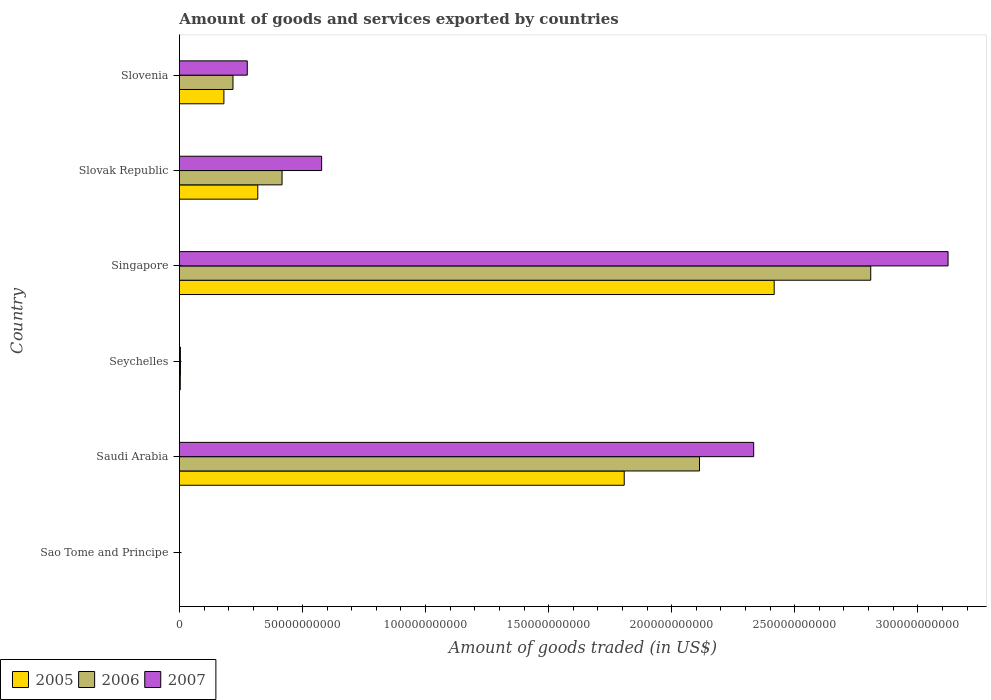How many different coloured bars are there?
Offer a very short reply. 3. How many bars are there on the 1st tick from the bottom?
Your answer should be compact. 3. What is the label of the 6th group of bars from the top?
Offer a very short reply. Sao Tome and Principe. In how many cases, is the number of bars for a given country not equal to the number of legend labels?
Keep it short and to the point. 0. What is the total amount of goods and services exported in 2005 in Sao Tome and Principe?
Offer a very short reply. 6.79e+06. Across all countries, what is the maximum total amount of goods and services exported in 2006?
Your answer should be very brief. 2.81e+11. Across all countries, what is the minimum total amount of goods and services exported in 2005?
Provide a succinct answer. 6.79e+06. In which country was the total amount of goods and services exported in 2007 maximum?
Ensure brevity in your answer.  Singapore. In which country was the total amount of goods and services exported in 2005 minimum?
Offer a terse response. Sao Tome and Principe. What is the total total amount of goods and services exported in 2006 in the graph?
Keep it short and to the point. 5.56e+11. What is the difference between the total amount of goods and services exported in 2007 in Sao Tome and Principe and that in Seychelles?
Offer a terse response. -3.91e+08. What is the difference between the total amount of goods and services exported in 2006 in Singapore and the total amount of goods and services exported in 2007 in Seychelles?
Give a very brief answer. 2.80e+11. What is the average total amount of goods and services exported in 2005 per country?
Provide a short and direct response. 7.88e+1. What is the difference between the total amount of goods and services exported in 2006 and total amount of goods and services exported in 2007 in Saudi Arabia?
Offer a terse response. -2.20e+1. In how many countries, is the total amount of goods and services exported in 2006 greater than 200000000000 US$?
Offer a terse response. 2. What is the ratio of the total amount of goods and services exported in 2006 in Seychelles to that in Slovak Republic?
Offer a very short reply. 0.01. Is the total amount of goods and services exported in 2006 in Saudi Arabia less than that in Singapore?
Your answer should be compact. Yes. Is the difference between the total amount of goods and services exported in 2006 in Sao Tome and Principe and Saudi Arabia greater than the difference between the total amount of goods and services exported in 2007 in Sao Tome and Principe and Saudi Arabia?
Offer a very short reply. Yes. What is the difference between the highest and the second highest total amount of goods and services exported in 2005?
Offer a very short reply. 6.09e+1. What is the difference between the highest and the lowest total amount of goods and services exported in 2006?
Offer a terse response. 2.81e+11. In how many countries, is the total amount of goods and services exported in 2005 greater than the average total amount of goods and services exported in 2005 taken over all countries?
Give a very brief answer. 2. What does the 2nd bar from the bottom in Sao Tome and Principe represents?
Your response must be concise. 2006. How many bars are there?
Offer a terse response. 18. How many legend labels are there?
Offer a very short reply. 3. What is the title of the graph?
Ensure brevity in your answer.  Amount of goods and services exported by countries. Does "1964" appear as one of the legend labels in the graph?
Offer a very short reply. No. What is the label or title of the X-axis?
Offer a terse response. Amount of goods traded (in US$). What is the Amount of goods traded (in US$) of 2005 in Sao Tome and Principe?
Keep it short and to the point. 6.79e+06. What is the Amount of goods traded (in US$) in 2006 in Sao Tome and Principe?
Make the answer very short. 7.71e+06. What is the Amount of goods traded (in US$) of 2007 in Sao Tome and Principe?
Keep it short and to the point. 6.81e+06. What is the Amount of goods traded (in US$) of 2005 in Saudi Arabia?
Give a very brief answer. 1.81e+11. What is the Amount of goods traded (in US$) in 2006 in Saudi Arabia?
Give a very brief answer. 2.11e+11. What is the Amount of goods traded (in US$) of 2007 in Saudi Arabia?
Make the answer very short. 2.33e+11. What is the Amount of goods traded (in US$) in 2005 in Seychelles?
Ensure brevity in your answer.  3.50e+08. What is the Amount of goods traded (in US$) in 2006 in Seychelles?
Provide a succinct answer. 4.19e+08. What is the Amount of goods traded (in US$) of 2007 in Seychelles?
Offer a terse response. 3.98e+08. What is the Amount of goods traded (in US$) in 2005 in Singapore?
Keep it short and to the point. 2.42e+11. What is the Amount of goods traded (in US$) in 2006 in Singapore?
Your response must be concise. 2.81e+11. What is the Amount of goods traded (in US$) in 2007 in Singapore?
Offer a very short reply. 3.12e+11. What is the Amount of goods traded (in US$) in 2005 in Slovak Republic?
Make the answer very short. 3.18e+1. What is the Amount of goods traded (in US$) of 2006 in Slovak Republic?
Your response must be concise. 4.17e+1. What is the Amount of goods traded (in US$) in 2007 in Slovak Republic?
Make the answer very short. 5.78e+1. What is the Amount of goods traded (in US$) in 2005 in Slovenia?
Provide a short and direct response. 1.81e+1. What is the Amount of goods traded (in US$) of 2006 in Slovenia?
Your response must be concise. 2.18e+1. What is the Amount of goods traded (in US$) of 2007 in Slovenia?
Provide a short and direct response. 2.76e+1. Across all countries, what is the maximum Amount of goods traded (in US$) in 2005?
Offer a terse response. 2.42e+11. Across all countries, what is the maximum Amount of goods traded (in US$) of 2006?
Provide a short and direct response. 2.81e+11. Across all countries, what is the maximum Amount of goods traded (in US$) of 2007?
Ensure brevity in your answer.  3.12e+11. Across all countries, what is the minimum Amount of goods traded (in US$) of 2005?
Your answer should be very brief. 6.79e+06. Across all countries, what is the minimum Amount of goods traded (in US$) of 2006?
Offer a very short reply. 7.71e+06. Across all countries, what is the minimum Amount of goods traded (in US$) of 2007?
Ensure brevity in your answer.  6.81e+06. What is the total Amount of goods traded (in US$) of 2005 in the graph?
Give a very brief answer. 4.73e+11. What is the total Amount of goods traded (in US$) of 2006 in the graph?
Make the answer very short. 5.56e+11. What is the total Amount of goods traded (in US$) of 2007 in the graph?
Ensure brevity in your answer.  6.31e+11. What is the difference between the Amount of goods traded (in US$) in 2005 in Sao Tome and Principe and that in Saudi Arabia?
Your answer should be compact. -1.81e+11. What is the difference between the Amount of goods traded (in US$) of 2006 in Sao Tome and Principe and that in Saudi Arabia?
Make the answer very short. -2.11e+11. What is the difference between the Amount of goods traded (in US$) in 2007 in Sao Tome and Principe and that in Saudi Arabia?
Your answer should be very brief. -2.33e+11. What is the difference between the Amount of goods traded (in US$) of 2005 in Sao Tome and Principe and that in Seychelles?
Offer a terse response. -3.43e+08. What is the difference between the Amount of goods traded (in US$) of 2006 in Sao Tome and Principe and that in Seychelles?
Keep it short and to the point. -4.11e+08. What is the difference between the Amount of goods traded (in US$) in 2007 in Sao Tome and Principe and that in Seychelles?
Give a very brief answer. -3.91e+08. What is the difference between the Amount of goods traded (in US$) of 2005 in Sao Tome and Principe and that in Singapore?
Provide a short and direct response. -2.42e+11. What is the difference between the Amount of goods traded (in US$) in 2006 in Sao Tome and Principe and that in Singapore?
Your answer should be very brief. -2.81e+11. What is the difference between the Amount of goods traded (in US$) of 2007 in Sao Tome and Principe and that in Singapore?
Provide a succinct answer. -3.12e+11. What is the difference between the Amount of goods traded (in US$) of 2005 in Sao Tome and Principe and that in Slovak Republic?
Your answer should be very brief. -3.18e+1. What is the difference between the Amount of goods traded (in US$) of 2006 in Sao Tome and Principe and that in Slovak Republic?
Offer a very short reply. -4.17e+1. What is the difference between the Amount of goods traded (in US$) of 2007 in Sao Tome and Principe and that in Slovak Republic?
Provide a short and direct response. -5.78e+1. What is the difference between the Amount of goods traded (in US$) in 2005 in Sao Tome and Principe and that in Slovenia?
Offer a very short reply. -1.81e+1. What is the difference between the Amount of goods traded (in US$) of 2006 in Sao Tome and Principe and that in Slovenia?
Your answer should be very brief. -2.18e+1. What is the difference between the Amount of goods traded (in US$) of 2007 in Sao Tome and Principe and that in Slovenia?
Your answer should be very brief. -2.76e+1. What is the difference between the Amount of goods traded (in US$) in 2005 in Saudi Arabia and that in Seychelles?
Provide a short and direct response. 1.80e+11. What is the difference between the Amount of goods traded (in US$) of 2006 in Saudi Arabia and that in Seychelles?
Make the answer very short. 2.11e+11. What is the difference between the Amount of goods traded (in US$) of 2007 in Saudi Arabia and that in Seychelles?
Offer a very short reply. 2.33e+11. What is the difference between the Amount of goods traded (in US$) in 2005 in Saudi Arabia and that in Singapore?
Your answer should be compact. -6.09e+1. What is the difference between the Amount of goods traded (in US$) of 2006 in Saudi Arabia and that in Singapore?
Ensure brevity in your answer.  -6.96e+1. What is the difference between the Amount of goods traded (in US$) in 2007 in Saudi Arabia and that in Singapore?
Your answer should be very brief. -7.90e+1. What is the difference between the Amount of goods traded (in US$) of 2005 in Saudi Arabia and that in Slovak Republic?
Keep it short and to the point. 1.49e+11. What is the difference between the Amount of goods traded (in US$) in 2006 in Saudi Arabia and that in Slovak Republic?
Keep it short and to the point. 1.70e+11. What is the difference between the Amount of goods traded (in US$) in 2007 in Saudi Arabia and that in Slovak Republic?
Provide a succinct answer. 1.76e+11. What is the difference between the Amount of goods traded (in US$) of 2005 in Saudi Arabia and that in Slovenia?
Make the answer very short. 1.63e+11. What is the difference between the Amount of goods traded (in US$) in 2006 in Saudi Arabia and that in Slovenia?
Offer a very short reply. 1.90e+11. What is the difference between the Amount of goods traded (in US$) in 2007 in Saudi Arabia and that in Slovenia?
Provide a succinct answer. 2.06e+11. What is the difference between the Amount of goods traded (in US$) in 2005 in Seychelles and that in Singapore?
Your answer should be compact. -2.41e+11. What is the difference between the Amount of goods traded (in US$) of 2006 in Seychelles and that in Singapore?
Your answer should be compact. -2.80e+11. What is the difference between the Amount of goods traded (in US$) of 2007 in Seychelles and that in Singapore?
Provide a short and direct response. -3.12e+11. What is the difference between the Amount of goods traded (in US$) in 2005 in Seychelles and that in Slovak Republic?
Your response must be concise. -3.15e+1. What is the difference between the Amount of goods traded (in US$) of 2006 in Seychelles and that in Slovak Republic?
Your response must be concise. -4.13e+1. What is the difference between the Amount of goods traded (in US$) in 2007 in Seychelles and that in Slovak Republic?
Keep it short and to the point. -5.74e+1. What is the difference between the Amount of goods traded (in US$) of 2005 in Seychelles and that in Slovenia?
Make the answer very short. -1.77e+1. What is the difference between the Amount of goods traded (in US$) in 2006 in Seychelles and that in Slovenia?
Keep it short and to the point. -2.13e+1. What is the difference between the Amount of goods traded (in US$) in 2007 in Seychelles and that in Slovenia?
Provide a succinct answer. -2.72e+1. What is the difference between the Amount of goods traded (in US$) in 2005 in Singapore and that in Slovak Republic?
Ensure brevity in your answer.  2.10e+11. What is the difference between the Amount of goods traded (in US$) in 2006 in Singapore and that in Slovak Republic?
Offer a very short reply. 2.39e+11. What is the difference between the Amount of goods traded (in US$) in 2007 in Singapore and that in Slovak Republic?
Offer a very short reply. 2.54e+11. What is the difference between the Amount of goods traded (in US$) in 2005 in Singapore and that in Slovenia?
Keep it short and to the point. 2.24e+11. What is the difference between the Amount of goods traded (in US$) of 2006 in Singapore and that in Slovenia?
Provide a succinct answer. 2.59e+11. What is the difference between the Amount of goods traded (in US$) of 2007 in Singapore and that in Slovenia?
Make the answer very short. 2.85e+11. What is the difference between the Amount of goods traded (in US$) of 2005 in Slovak Republic and that in Slovenia?
Your response must be concise. 1.38e+1. What is the difference between the Amount of goods traded (in US$) in 2006 in Slovak Republic and that in Slovenia?
Your response must be concise. 1.99e+1. What is the difference between the Amount of goods traded (in US$) of 2007 in Slovak Republic and that in Slovenia?
Keep it short and to the point. 3.02e+1. What is the difference between the Amount of goods traded (in US$) in 2005 in Sao Tome and Principe and the Amount of goods traded (in US$) in 2006 in Saudi Arabia?
Provide a short and direct response. -2.11e+11. What is the difference between the Amount of goods traded (in US$) of 2005 in Sao Tome and Principe and the Amount of goods traded (in US$) of 2007 in Saudi Arabia?
Provide a short and direct response. -2.33e+11. What is the difference between the Amount of goods traded (in US$) in 2006 in Sao Tome and Principe and the Amount of goods traded (in US$) in 2007 in Saudi Arabia?
Your answer should be very brief. -2.33e+11. What is the difference between the Amount of goods traded (in US$) of 2005 in Sao Tome and Principe and the Amount of goods traded (in US$) of 2006 in Seychelles?
Offer a terse response. -4.12e+08. What is the difference between the Amount of goods traded (in US$) of 2005 in Sao Tome and Principe and the Amount of goods traded (in US$) of 2007 in Seychelles?
Your response must be concise. -3.91e+08. What is the difference between the Amount of goods traded (in US$) in 2006 in Sao Tome and Principe and the Amount of goods traded (in US$) in 2007 in Seychelles?
Give a very brief answer. -3.90e+08. What is the difference between the Amount of goods traded (in US$) of 2005 in Sao Tome and Principe and the Amount of goods traded (in US$) of 2006 in Singapore?
Make the answer very short. -2.81e+11. What is the difference between the Amount of goods traded (in US$) of 2005 in Sao Tome and Principe and the Amount of goods traded (in US$) of 2007 in Singapore?
Your answer should be very brief. -3.12e+11. What is the difference between the Amount of goods traded (in US$) of 2006 in Sao Tome and Principe and the Amount of goods traded (in US$) of 2007 in Singapore?
Keep it short and to the point. -3.12e+11. What is the difference between the Amount of goods traded (in US$) in 2005 in Sao Tome and Principe and the Amount of goods traded (in US$) in 2006 in Slovak Republic?
Provide a succinct answer. -4.17e+1. What is the difference between the Amount of goods traded (in US$) in 2005 in Sao Tome and Principe and the Amount of goods traded (in US$) in 2007 in Slovak Republic?
Your answer should be very brief. -5.78e+1. What is the difference between the Amount of goods traded (in US$) in 2006 in Sao Tome and Principe and the Amount of goods traded (in US$) in 2007 in Slovak Republic?
Make the answer very short. -5.78e+1. What is the difference between the Amount of goods traded (in US$) in 2005 in Sao Tome and Principe and the Amount of goods traded (in US$) in 2006 in Slovenia?
Your answer should be very brief. -2.18e+1. What is the difference between the Amount of goods traded (in US$) of 2005 in Sao Tome and Principe and the Amount of goods traded (in US$) of 2007 in Slovenia?
Ensure brevity in your answer.  -2.76e+1. What is the difference between the Amount of goods traded (in US$) of 2006 in Sao Tome and Principe and the Amount of goods traded (in US$) of 2007 in Slovenia?
Give a very brief answer. -2.76e+1. What is the difference between the Amount of goods traded (in US$) in 2005 in Saudi Arabia and the Amount of goods traded (in US$) in 2006 in Seychelles?
Offer a very short reply. 1.80e+11. What is the difference between the Amount of goods traded (in US$) in 2005 in Saudi Arabia and the Amount of goods traded (in US$) in 2007 in Seychelles?
Offer a very short reply. 1.80e+11. What is the difference between the Amount of goods traded (in US$) in 2006 in Saudi Arabia and the Amount of goods traded (in US$) in 2007 in Seychelles?
Keep it short and to the point. 2.11e+11. What is the difference between the Amount of goods traded (in US$) of 2005 in Saudi Arabia and the Amount of goods traded (in US$) of 2006 in Singapore?
Provide a short and direct response. -1.00e+11. What is the difference between the Amount of goods traded (in US$) of 2005 in Saudi Arabia and the Amount of goods traded (in US$) of 2007 in Singapore?
Provide a short and direct response. -1.32e+11. What is the difference between the Amount of goods traded (in US$) of 2006 in Saudi Arabia and the Amount of goods traded (in US$) of 2007 in Singapore?
Your response must be concise. -1.01e+11. What is the difference between the Amount of goods traded (in US$) in 2005 in Saudi Arabia and the Amount of goods traded (in US$) in 2006 in Slovak Republic?
Your answer should be compact. 1.39e+11. What is the difference between the Amount of goods traded (in US$) in 2005 in Saudi Arabia and the Amount of goods traded (in US$) in 2007 in Slovak Republic?
Make the answer very short. 1.23e+11. What is the difference between the Amount of goods traded (in US$) of 2006 in Saudi Arabia and the Amount of goods traded (in US$) of 2007 in Slovak Republic?
Keep it short and to the point. 1.54e+11. What is the difference between the Amount of goods traded (in US$) in 2005 in Saudi Arabia and the Amount of goods traded (in US$) in 2006 in Slovenia?
Offer a terse response. 1.59e+11. What is the difference between the Amount of goods traded (in US$) in 2005 in Saudi Arabia and the Amount of goods traded (in US$) in 2007 in Slovenia?
Offer a very short reply. 1.53e+11. What is the difference between the Amount of goods traded (in US$) in 2006 in Saudi Arabia and the Amount of goods traded (in US$) in 2007 in Slovenia?
Ensure brevity in your answer.  1.84e+11. What is the difference between the Amount of goods traded (in US$) in 2005 in Seychelles and the Amount of goods traded (in US$) in 2006 in Singapore?
Your answer should be very brief. -2.81e+11. What is the difference between the Amount of goods traded (in US$) of 2005 in Seychelles and the Amount of goods traded (in US$) of 2007 in Singapore?
Make the answer very short. -3.12e+11. What is the difference between the Amount of goods traded (in US$) of 2006 in Seychelles and the Amount of goods traded (in US$) of 2007 in Singapore?
Provide a succinct answer. -3.12e+11. What is the difference between the Amount of goods traded (in US$) in 2005 in Seychelles and the Amount of goods traded (in US$) in 2006 in Slovak Republic?
Offer a very short reply. -4.14e+1. What is the difference between the Amount of goods traded (in US$) of 2005 in Seychelles and the Amount of goods traded (in US$) of 2007 in Slovak Republic?
Provide a short and direct response. -5.74e+1. What is the difference between the Amount of goods traded (in US$) in 2006 in Seychelles and the Amount of goods traded (in US$) in 2007 in Slovak Republic?
Ensure brevity in your answer.  -5.74e+1. What is the difference between the Amount of goods traded (in US$) in 2005 in Seychelles and the Amount of goods traded (in US$) in 2006 in Slovenia?
Make the answer very short. -2.14e+1. What is the difference between the Amount of goods traded (in US$) of 2005 in Seychelles and the Amount of goods traded (in US$) of 2007 in Slovenia?
Your answer should be compact. -2.72e+1. What is the difference between the Amount of goods traded (in US$) of 2006 in Seychelles and the Amount of goods traded (in US$) of 2007 in Slovenia?
Give a very brief answer. -2.72e+1. What is the difference between the Amount of goods traded (in US$) in 2005 in Singapore and the Amount of goods traded (in US$) in 2006 in Slovak Republic?
Give a very brief answer. 2.00e+11. What is the difference between the Amount of goods traded (in US$) in 2005 in Singapore and the Amount of goods traded (in US$) in 2007 in Slovak Republic?
Make the answer very short. 1.84e+11. What is the difference between the Amount of goods traded (in US$) of 2006 in Singapore and the Amount of goods traded (in US$) of 2007 in Slovak Republic?
Offer a very short reply. 2.23e+11. What is the difference between the Amount of goods traded (in US$) of 2005 in Singapore and the Amount of goods traded (in US$) of 2006 in Slovenia?
Ensure brevity in your answer.  2.20e+11. What is the difference between the Amount of goods traded (in US$) in 2005 in Singapore and the Amount of goods traded (in US$) in 2007 in Slovenia?
Your answer should be very brief. 2.14e+11. What is the difference between the Amount of goods traded (in US$) in 2006 in Singapore and the Amount of goods traded (in US$) in 2007 in Slovenia?
Your answer should be very brief. 2.53e+11. What is the difference between the Amount of goods traded (in US$) of 2005 in Slovak Republic and the Amount of goods traded (in US$) of 2006 in Slovenia?
Your answer should be compact. 1.01e+1. What is the difference between the Amount of goods traded (in US$) of 2005 in Slovak Republic and the Amount of goods traded (in US$) of 2007 in Slovenia?
Offer a terse response. 4.27e+09. What is the difference between the Amount of goods traded (in US$) of 2006 in Slovak Republic and the Amount of goods traded (in US$) of 2007 in Slovenia?
Make the answer very short. 1.41e+1. What is the average Amount of goods traded (in US$) in 2005 per country?
Give a very brief answer. 7.88e+1. What is the average Amount of goods traded (in US$) of 2006 per country?
Ensure brevity in your answer.  9.27e+1. What is the average Amount of goods traded (in US$) in 2007 per country?
Ensure brevity in your answer.  1.05e+11. What is the difference between the Amount of goods traded (in US$) of 2005 and Amount of goods traded (in US$) of 2006 in Sao Tome and Principe?
Make the answer very short. -9.20e+05. What is the difference between the Amount of goods traded (in US$) in 2005 and Amount of goods traded (in US$) in 2007 in Sao Tome and Principe?
Provide a succinct answer. -1.96e+04. What is the difference between the Amount of goods traded (in US$) in 2006 and Amount of goods traded (in US$) in 2007 in Sao Tome and Principe?
Ensure brevity in your answer.  9.00e+05. What is the difference between the Amount of goods traded (in US$) of 2005 and Amount of goods traded (in US$) of 2006 in Saudi Arabia?
Your response must be concise. -3.06e+1. What is the difference between the Amount of goods traded (in US$) of 2005 and Amount of goods traded (in US$) of 2007 in Saudi Arabia?
Keep it short and to the point. -5.26e+1. What is the difference between the Amount of goods traded (in US$) of 2006 and Amount of goods traded (in US$) of 2007 in Saudi Arabia?
Your response must be concise. -2.20e+1. What is the difference between the Amount of goods traded (in US$) in 2005 and Amount of goods traded (in US$) in 2006 in Seychelles?
Offer a very short reply. -6.91e+07. What is the difference between the Amount of goods traded (in US$) of 2005 and Amount of goods traded (in US$) of 2007 in Seychelles?
Provide a succinct answer. -4.75e+07. What is the difference between the Amount of goods traded (in US$) in 2006 and Amount of goods traded (in US$) in 2007 in Seychelles?
Keep it short and to the point. 2.16e+07. What is the difference between the Amount of goods traded (in US$) in 2005 and Amount of goods traded (in US$) in 2006 in Singapore?
Provide a succinct answer. -3.92e+1. What is the difference between the Amount of goods traded (in US$) in 2005 and Amount of goods traded (in US$) in 2007 in Singapore?
Your answer should be compact. -7.06e+1. What is the difference between the Amount of goods traded (in US$) of 2006 and Amount of goods traded (in US$) of 2007 in Singapore?
Your answer should be compact. -3.14e+1. What is the difference between the Amount of goods traded (in US$) in 2005 and Amount of goods traded (in US$) in 2006 in Slovak Republic?
Offer a very short reply. -9.86e+09. What is the difference between the Amount of goods traded (in US$) of 2005 and Amount of goods traded (in US$) of 2007 in Slovak Republic?
Make the answer very short. -2.59e+1. What is the difference between the Amount of goods traded (in US$) in 2006 and Amount of goods traded (in US$) in 2007 in Slovak Republic?
Your response must be concise. -1.61e+1. What is the difference between the Amount of goods traded (in US$) in 2005 and Amount of goods traded (in US$) in 2006 in Slovenia?
Make the answer very short. -3.69e+09. What is the difference between the Amount of goods traded (in US$) in 2005 and Amount of goods traded (in US$) in 2007 in Slovenia?
Your response must be concise. -9.50e+09. What is the difference between the Amount of goods traded (in US$) in 2006 and Amount of goods traded (in US$) in 2007 in Slovenia?
Your response must be concise. -5.81e+09. What is the ratio of the Amount of goods traded (in US$) of 2005 in Sao Tome and Principe to that in Saudi Arabia?
Give a very brief answer. 0. What is the ratio of the Amount of goods traded (in US$) of 2006 in Sao Tome and Principe to that in Saudi Arabia?
Ensure brevity in your answer.  0. What is the ratio of the Amount of goods traded (in US$) in 2007 in Sao Tome and Principe to that in Saudi Arabia?
Ensure brevity in your answer.  0. What is the ratio of the Amount of goods traded (in US$) in 2005 in Sao Tome and Principe to that in Seychelles?
Make the answer very short. 0.02. What is the ratio of the Amount of goods traded (in US$) of 2006 in Sao Tome and Principe to that in Seychelles?
Your response must be concise. 0.02. What is the ratio of the Amount of goods traded (in US$) of 2007 in Sao Tome and Principe to that in Seychelles?
Provide a short and direct response. 0.02. What is the ratio of the Amount of goods traded (in US$) of 2006 in Sao Tome and Principe to that in Singapore?
Offer a very short reply. 0. What is the ratio of the Amount of goods traded (in US$) in 2005 in Sao Tome and Principe to that in Slovak Republic?
Your response must be concise. 0. What is the ratio of the Amount of goods traded (in US$) in 2006 in Sao Tome and Principe to that in Slovak Republic?
Offer a very short reply. 0. What is the ratio of the Amount of goods traded (in US$) in 2007 in Sao Tome and Principe to that in Slovak Republic?
Offer a very short reply. 0. What is the ratio of the Amount of goods traded (in US$) of 2007 in Sao Tome and Principe to that in Slovenia?
Provide a short and direct response. 0. What is the ratio of the Amount of goods traded (in US$) of 2005 in Saudi Arabia to that in Seychelles?
Make the answer very short. 516.17. What is the ratio of the Amount of goods traded (in US$) of 2006 in Saudi Arabia to that in Seychelles?
Provide a short and direct response. 504.06. What is the ratio of the Amount of goods traded (in US$) of 2007 in Saudi Arabia to that in Seychelles?
Offer a very short reply. 586.87. What is the ratio of the Amount of goods traded (in US$) in 2005 in Saudi Arabia to that in Singapore?
Keep it short and to the point. 0.75. What is the ratio of the Amount of goods traded (in US$) in 2006 in Saudi Arabia to that in Singapore?
Your response must be concise. 0.75. What is the ratio of the Amount of goods traded (in US$) in 2007 in Saudi Arabia to that in Singapore?
Ensure brevity in your answer.  0.75. What is the ratio of the Amount of goods traded (in US$) in 2005 in Saudi Arabia to that in Slovak Republic?
Your response must be concise. 5.68. What is the ratio of the Amount of goods traded (in US$) in 2006 in Saudi Arabia to that in Slovak Republic?
Offer a terse response. 5.07. What is the ratio of the Amount of goods traded (in US$) of 2007 in Saudi Arabia to that in Slovak Republic?
Your answer should be very brief. 4.04. What is the ratio of the Amount of goods traded (in US$) in 2005 in Saudi Arabia to that in Slovenia?
Your response must be concise. 10. What is the ratio of the Amount of goods traded (in US$) of 2006 in Saudi Arabia to that in Slovenia?
Offer a very short reply. 9.71. What is the ratio of the Amount of goods traded (in US$) of 2007 in Saudi Arabia to that in Slovenia?
Your answer should be very brief. 8.46. What is the ratio of the Amount of goods traded (in US$) in 2005 in Seychelles to that in Singapore?
Make the answer very short. 0. What is the ratio of the Amount of goods traded (in US$) of 2006 in Seychelles to that in Singapore?
Your answer should be compact. 0. What is the ratio of the Amount of goods traded (in US$) of 2007 in Seychelles to that in Singapore?
Make the answer very short. 0. What is the ratio of the Amount of goods traded (in US$) of 2005 in Seychelles to that in Slovak Republic?
Your answer should be compact. 0.01. What is the ratio of the Amount of goods traded (in US$) in 2006 in Seychelles to that in Slovak Republic?
Give a very brief answer. 0.01. What is the ratio of the Amount of goods traded (in US$) of 2007 in Seychelles to that in Slovak Republic?
Ensure brevity in your answer.  0.01. What is the ratio of the Amount of goods traded (in US$) of 2005 in Seychelles to that in Slovenia?
Make the answer very short. 0.02. What is the ratio of the Amount of goods traded (in US$) of 2006 in Seychelles to that in Slovenia?
Keep it short and to the point. 0.02. What is the ratio of the Amount of goods traded (in US$) in 2007 in Seychelles to that in Slovenia?
Offer a very short reply. 0.01. What is the ratio of the Amount of goods traded (in US$) of 2005 in Singapore to that in Slovak Republic?
Give a very brief answer. 7.59. What is the ratio of the Amount of goods traded (in US$) of 2006 in Singapore to that in Slovak Republic?
Provide a succinct answer. 6.73. What is the ratio of the Amount of goods traded (in US$) in 2007 in Singapore to that in Slovak Republic?
Offer a very short reply. 5.4. What is the ratio of the Amount of goods traded (in US$) of 2005 in Singapore to that in Slovenia?
Offer a very short reply. 13.37. What is the ratio of the Amount of goods traded (in US$) in 2006 in Singapore to that in Slovenia?
Offer a terse response. 12.9. What is the ratio of the Amount of goods traded (in US$) in 2007 in Singapore to that in Slovenia?
Ensure brevity in your answer.  11.33. What is the ratio of the Amount of goods traded (in US$) in 2005 in Slovak Republic to that in Slovenia?
Provide a succinct answer. 1.76. What is the ratio of the Amount of goods traded (in US$) in 2006 in Slovak Republic to that in Slovenia?
Offer a terse response. 1.92. What is the ratio of the Amount of goods traded (in US$) of 2007 in Slovak Republic to that in Slovenia?
Your response must be concise. 2.1. What is the difference between the highest and the second highest Amount of goods traded (in US$) in 2005?
Your answer should be very brief. 6.09e+1. What is the difference between the highest and the second highest Amount of goods traded (in US$) of 2006?
Your response must be concise. 6.96e+1. What is the difference between the highest and the second highest Amount of goods traded (in US$) of 2007?
Offer a very short reply. 7.90e+1. What is the difference between the highest and the lowest Amount of goods traded (in US$) of 2005?
Provide a short and direct response. 2.42e+11. What is the difference between the highest and the lowest Amount of goods traded (in US$) of 2006?
Keep it short and to the point. 2.81e+11. What is the difference between the highest and the lowest Amount of goods traded (in US$) in 2007?
Keep it short and to the point. 3.12e+11. 